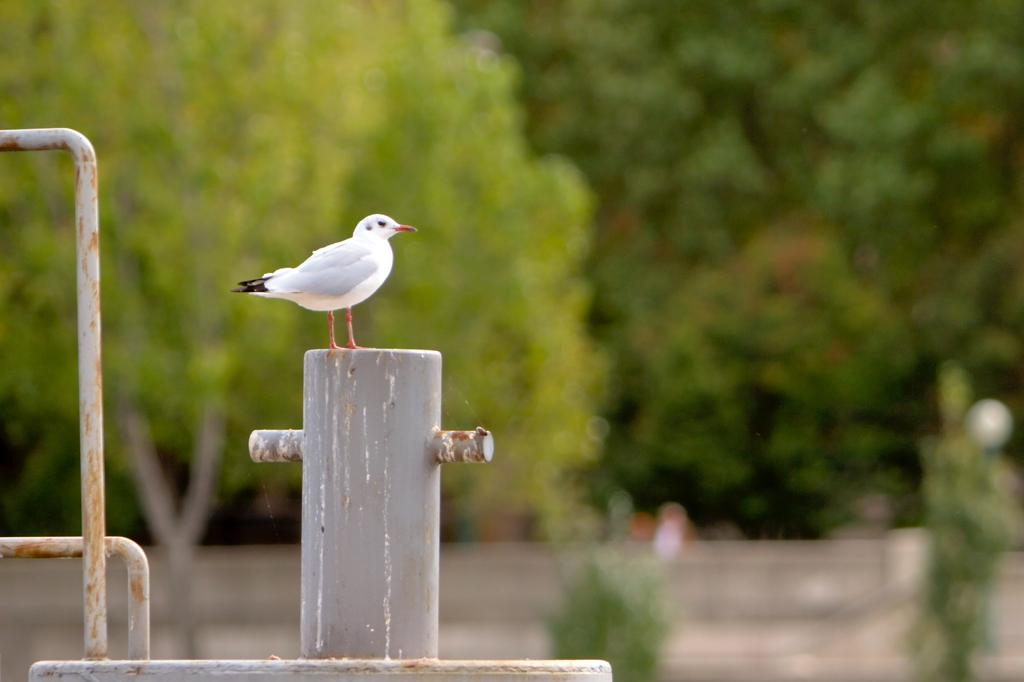What type of animal is present in the image? There is a bird in the image. What is the color of the bird? The bird is white in color. What is the bird sitting on? The bird is sitting on a metal object. What can be seen in the background of the image? There are trees visible in the image. How is the background of the image depicted? The background is blurred. What type of quill is the bird holding in the image? There is no quill present in the image; the bird is simply sitting on a metal object. 